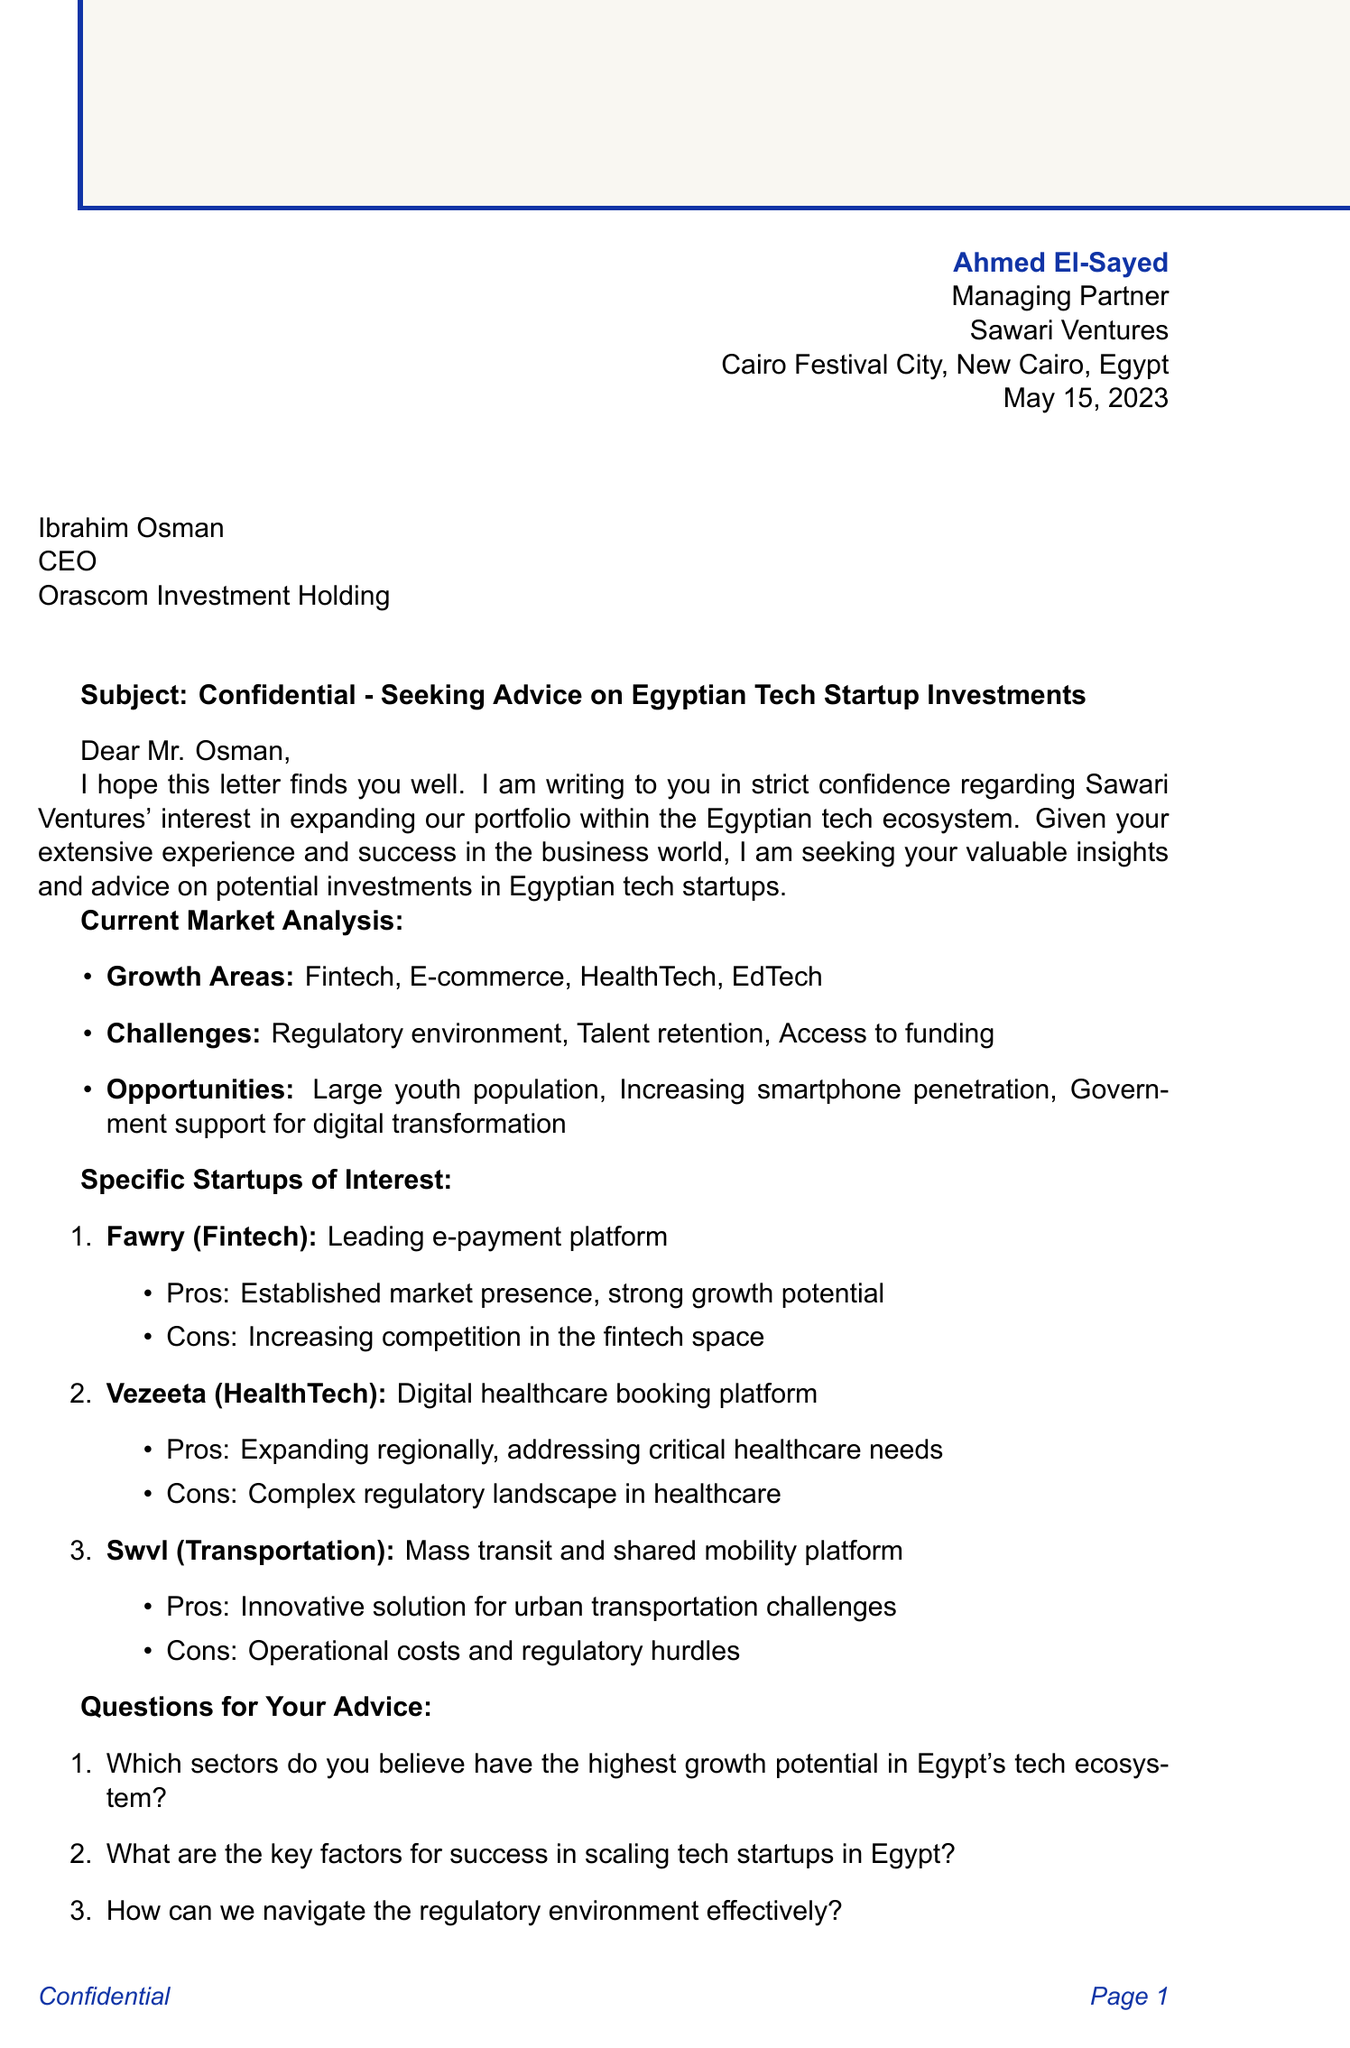What is the name of the sender? The sender of the letter is specifically mentioned in the letter header.
Answer: Ahmed El-Sayed What is the title of the recipient? The title of the recipient is included in the recipient information section.
Answer: CEO What is the date of the letter? The date is clearly stated in the letter header.
Answer: May 15, 2023 Which firm is interested in Egyptian tech startups? The firm expressing interest is indicated in the introduction section.
Answer: Sawari Ventures Name one of the growth areas in the current market analysis. The document lists several growth areas in the market analysis section.
Answer: Fintech What is one challenge mentioned in the current market analysis? The challenges can be found within the current market analysis section of the letter.
Answer: Regulatory environment What startup is described as a leading e-payment platform? The specific startup is mentioned in the section dedicated to specific startups of interest with its description.
Answer: Fawry What are the pros of Vezeeta? The pros of Vezeeta are outlined in the document under specific startups of interest.
Answer: Expanding regionally, addressing critical healthcare needs What is one of the questions seeking advice from the recipient? The questions for advice are clearly listed in the document's questions for advice section.
Answer: Which sectors do you believe have the highest growth potential in Egypt's tech ecosystem? What does the sender emphasize about the communication? The sender emphasizes a particular aspect regarding the nature of the communication in the closing remarks.
Answer: Confidential nature 